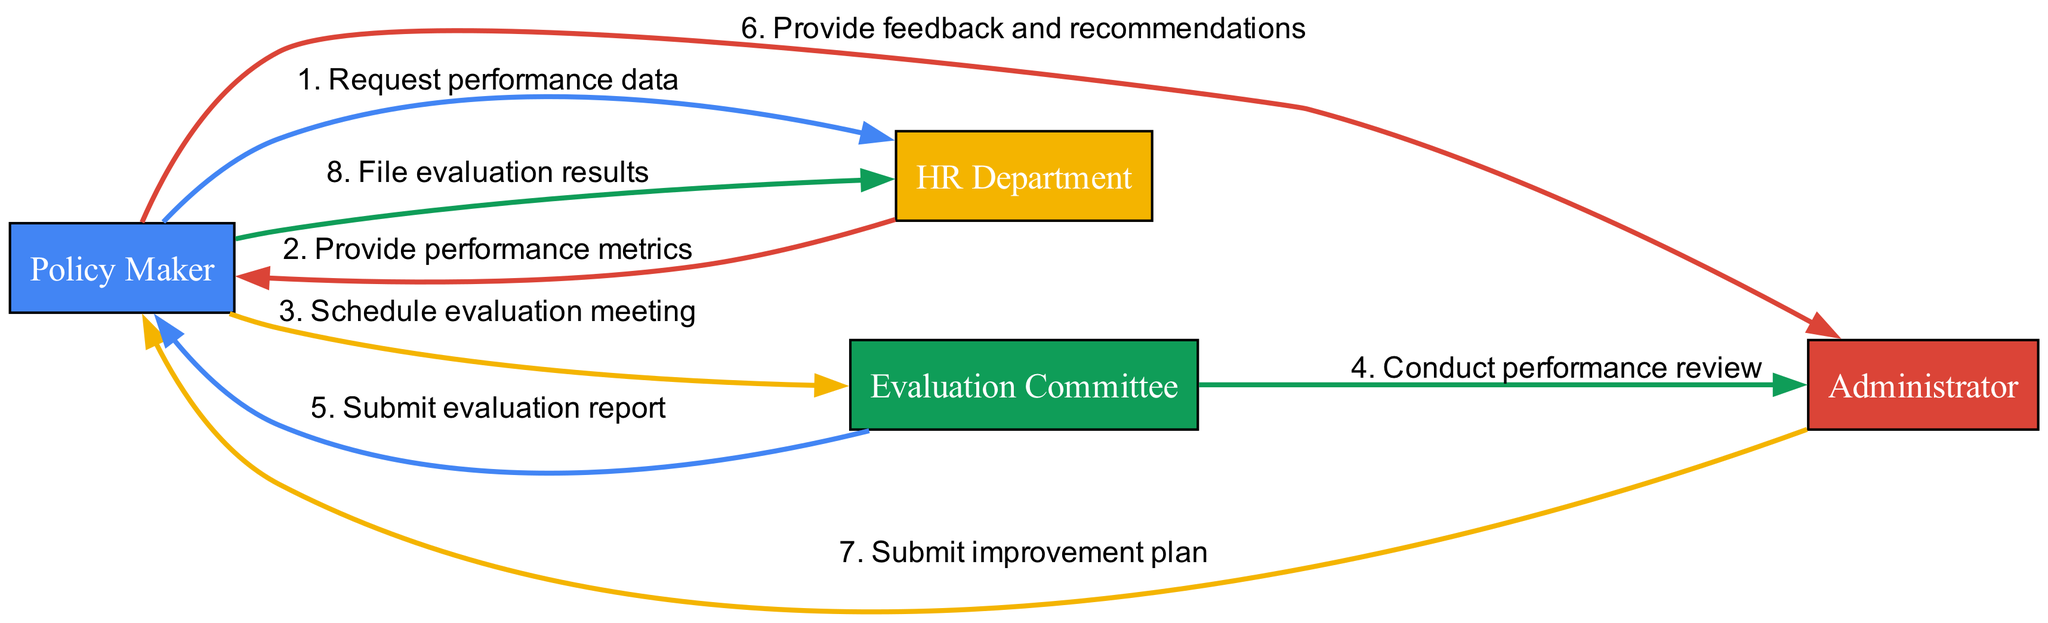What is the first message in the sequence? The first message in the sequence is from the Policy Maker to the HR Department requesting performance data.
Answer: Request performance data How many actors are there in the diagram? The diagram features four distinct actors: Policy Maker, Administrator, HR Department, and Evaluation Committee.
Answer: Four Who receives the evaluation report? The Evaluation Committee submits the evaluation report to the Policy Maker.
Answer: Policy Maker What does the Administrator submit after receiving feedback? After receiving feedback, the Administrator submits an improvement plan to the Policy Maker.
Answer: Improvement plan Which actor conducts the performance review? The Evaluation Committee is responsible for conducting the performance review of the Administrator.
Answer: Evaluation Committee What is the last action taken in the workflow? The workflow concludes with the filing of evaluation results by the Policy Maker to the HR Department.
Answer: File evaluation results How many steps are there in the sequence? There are a total of eight steps outlined in the sequence of actions performed by the actors.
Answer: Eight What is the relationship between the Policy Maker and the HR Department? The Policy Maker requests performance data from the HR Department and later files evaluation results with them, forming a communication loop.
Answer: Communication loop What message follows the performance review step? The message that follows the performance review step is the submission of the evaluation report by the Evaluation Committee to the Policy Maker.
Answer: Submit evaluation report 